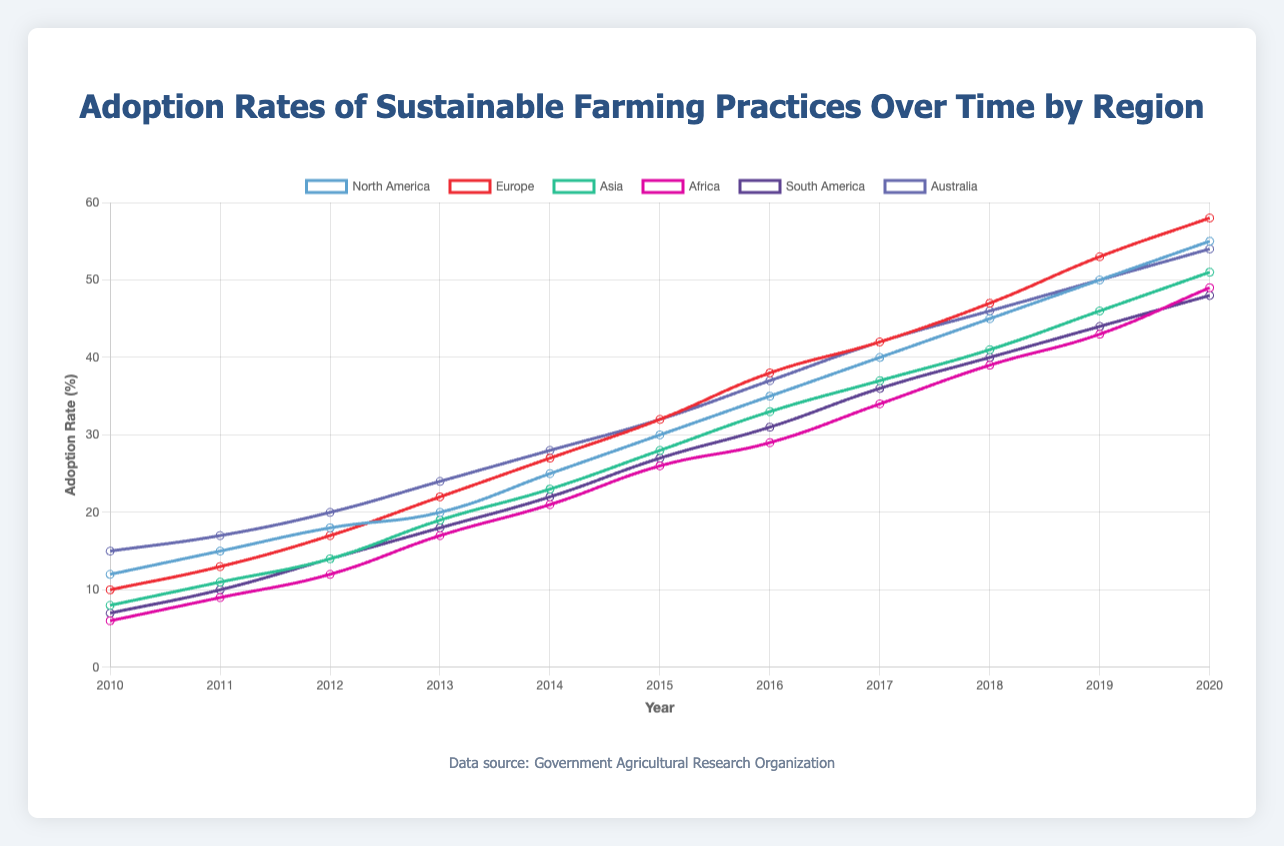Which region had the highest adoption rate of sustainable farming practices in 2020? First, identify the adoption rate for each region in 2020. Compare these values to determine the highest. North America: 55%, Europe: 58%, Asia: 51%, Africa: 49%, South America: 48%, Australia: 54%. Hence, Europe had the highest adoption rate in 2020.
Answer: Europe Which region showed the largest increase in adoption rate from 2010 to 2020? Calculate the increase for each region by subtracting the 2010 value from the 2020 value. North America: 55 - 12 = 43, Europe: 58 - 10 = 48, Asia: 51 - 8 = 43, Africa: 49 - 6 = 43, South America: 48 - 7 = 41, Australia: 54 - 15 = 39. Europe showed the largest increase.
Answer: Europe Among Africa and South America, which region had a higher adoption rate in 2017? Compare the adoption rates of Africa and South America in 2017. Africa: 34%, South America: 36%. South America had a higher adoption rate.
Answer: South America What is the average adoption rate across all regions in 2015? Sum the 2015 adoption rates for all regions and divide by the number of regions. (30 + 32 + 28 + 26 + 27 + 32) / 6 = 175 / 6 ≈ 29.17.
Answer: 29.17 Which region had a lower adoption rate in 2014, Asia or Australia? Compare the adoption rates for Asia and Australia in 2014. Asia: 23%, Australia: 28%. Asia had a lower adoption rate.
Answer: Asia Has North America consistently shown a year-over-year increase in adoption rates from 2010 to 2020? Check if the adoption rate increased each year in North America from 2010 to 2020. Each year: 12, 15, 18, 20, 25, 30, 35, 40, 45, 50, 55. Since each subsequent year has a higher value than the previous year, the increase is consistent.
Answer: Yes In which year did Europe surpass a 50% adoption rate? Identify the first year in which Europe’s adoption rate exceeds 50%. From the data, Europe surpassed 50% in 2019 (53%).
Answer: 2019 What is the difference between the highest adoption rate and the lowest adoption rate in 2020? Find the highest and lowest adoption rates in 2020 across all regions and calculate the difference. Highest: Europe: 58%, Lowest: Africa: 49%. The difference is 58 - 49 = 9.
Answer: 9 